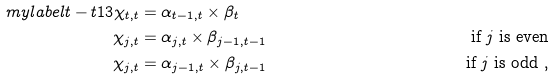<formula> <loc_0><loc_0><loc_500><loc_500>\ m y l a b e l { t - t 1 3 } \chi _ { t , t } & = \alpha _ { t - 1 , t } \times \beta _ { t } & \\ \chi _ { j , t } & = \alpha _ { j , t } \times \beta _ { j - 1 , t - 1 } & \text { if $j$ is even} \\ \chi _ { j , t } & = \alpha _ { j - 1 , t } \times \beta _ { j , t - 1 } & \text { if $j$ is odd } ,</formula> 